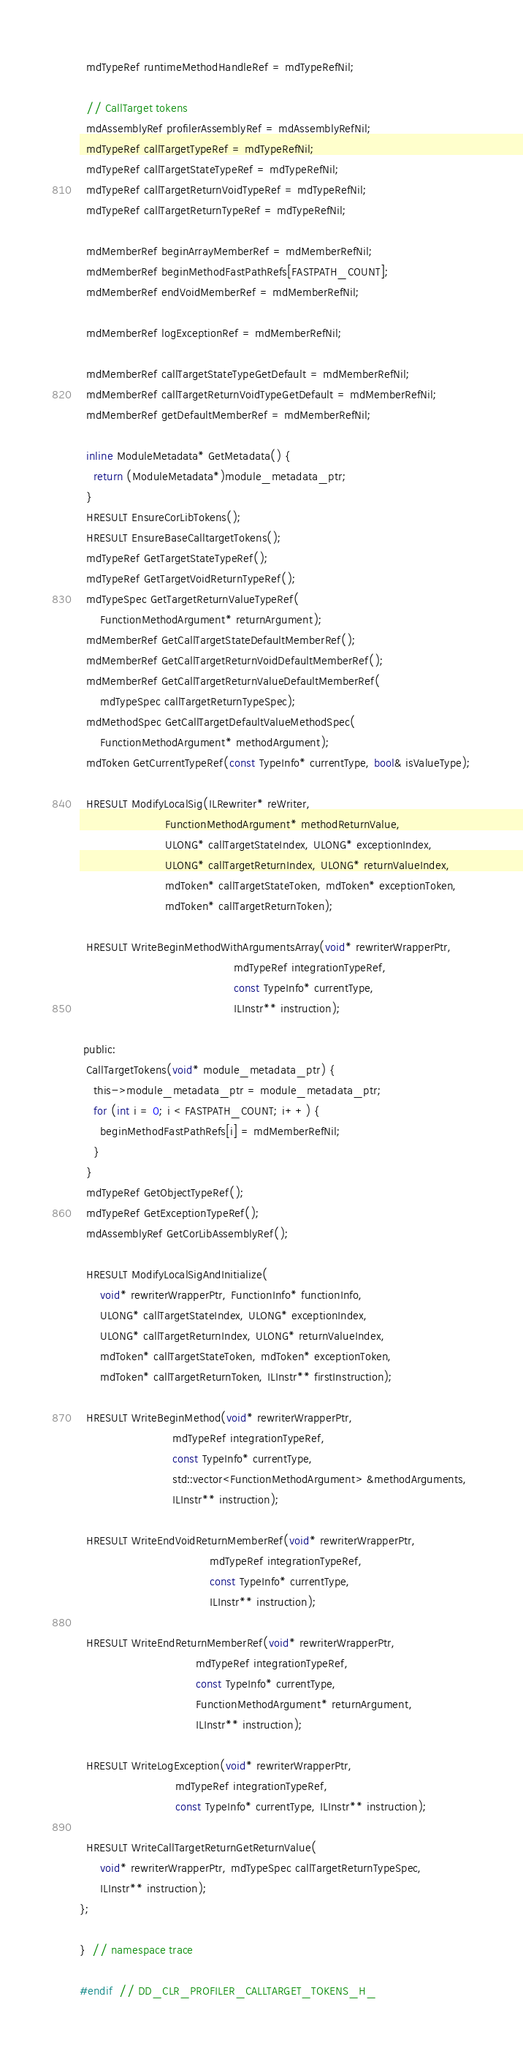<code> <loc_0><loc_0><loc_500><loc_500><_C_>  mdTypeRef runtimeMethodHandleRef = mdTypeRefNil;

  // CallTarget tokens
  mdAssemblyRef profilerAssemblyRef = mdAssemblyRefNil;
  mdTypeRef callTargetTypeRef = mdTypeRefNil;
  mdTypeRef callTargetStateTypeRef = mdTypeRefNil;
  mdTypeRef callTargetReturnVoidTypeRef = mdTypeRefNil;
  mdTypeRef callTargetReturnTypeRef = mdTypeRefNil;

  mdMemberRef beginArrayMemberRef = mdMemberRefNil;
  mdMemberRef beginMethodFastPathRefs[FASTPATH_COUNT];
  mdMemberRef endVoidMemberRef = mdMemberRefNil;

  mdMemberRef logExceptionRef = mdMemberRefNil;

  mdMemberRef callTargetStateTypeGetDefault = mdMemberRefNil;
  mdMemberRef callTargetReturnVoidTypeGetDefault = mdMemberRefNil;
  mdMemberRef getDefaultMemberRef = mdMemberRefNil;

  inline ModuleMetadata* GetMetadata() {
    return (ModuleMetadata*)module_metadata_ptr;
  }
  HRESULT EnsureCorLibTokens();
  HRESULT EnsureBaseCalltargetTokens();
  mdTypeRef GetTargetStateTypeRef();
  mdTypeRef GetTargetVoidReturnTypeRef();
  mdTypeSpec GetTargetReturnValueTypeRef(
      FunctionMethodArgument* returnArgument);
  mdMemberRef GetCallTargetStateDefaultMemberRef();
  mdMemberRef GetCallTargetReturnVoidDefaultMemberRef();
  mdMemberRef GetCallTargetReturnValueDefaultMemberRef(
      mdTypeSpec callTargetReturnTypeSpec);
  mdMethodSpec GetCallTargetDefaultValueMethodSpec(
      FunctionMethodArgument* methodArgument);
  mdToken GetCurrentTypeRef(const TypeInfo* currentType, bool& isValueType);

  HRESULT ModifyLocalSig(ILRewriter* reWriter,
                         FunctionMethodArgument* methodReturnValue,
                         ULONG* callTargetStateIndex, ULONG* exceptionIndex,
                         ULONG* callTargetReturnIndex, ULONG* returnValueIndex,
                         mdToken* callTargetStateToken, mdToken* exceptionToken,
                         mdToken* callTargetReturnToken);

  HRESULT WriteBeginMethodWithArgumentsArray(void* rewriterWrapperPtr,
                                             mdTypeRef integrationTypeRef,
                                             const TypeInfo* currentType,
                                             ILInstr** instruction);

 public:
  CallTargetTokens(void* module_metadata_ptr) {
    this->module_metadata_ptr = module_metadata_ptr;
    for (int i = 0; i < FASTPATH_COUNT; i++) {
      beginMethodFastPathRefs[i] = mdMemberRefNil;
    }
  }
  mdTypeRef GetObjectTypeRef();
  mdTypeRef GetExceptionTypeRef();
  mdAssemblyRef GetCorLibAssemblyRef();

  HRESULT ModifyLocalSigAndInitialize(
      void* rewriterWrapperPtr, FunctionInfo* functionInfo,
      ULONG* callTargetStateIndex, ULONG* exceptionIndex,
      ULONG* callTargetReturnIndex, ULONG* returnValueIndex,
      mdToken* callTargetStateToken, mdToken* exceptionToken,
      mdToken* callTargetReturnToken, ILInstr** firstInstruction);

  HRESULT WriteBeginMethod(void* rewriterWrapperPtr,
                           mdTypeRef integrationTypeRef,
                           const TypeInfo* currentType, 
                           std::vector<FunctionMethodArgument> &methodArguments,
                           ILInstr** instruction);

  HRESULT WriteEndVoidReturnMemberRef(void* rewriterWrapperPtr,
                                      mdTypeRef integrationTypeRef,
                                      const TypeInfo* currentType,
                                      ILInstr** instruction);

  HRESULT WriteEndReturnMemberRef(void* rewriterWrapperPtr,
                                  mdTypeRef integrationTypeRef,
                                  const TypeInfo* currentType,
                                  FunctionMethodArgument* returnArgument,
                                  ILInstr** instruction);

  HRESULT WriteLogException(void* rewriterWrapperPtr,
                            mdTypeRef integrationTypeRef,
                            const TypeInfo* currentType, ILInstr** instruction);

  HRESULT WriteCallTargetReturnGetReturnValue(
      void* rewriterWrapperPtr, mdTypeSpec callTargetReturnTypeSpec,
      ILInstr** instruction);
};

}  // namespace trace

#endif  // DD_CLR_PROFILER_CALLTARGET_TOKENS_H_</code> 